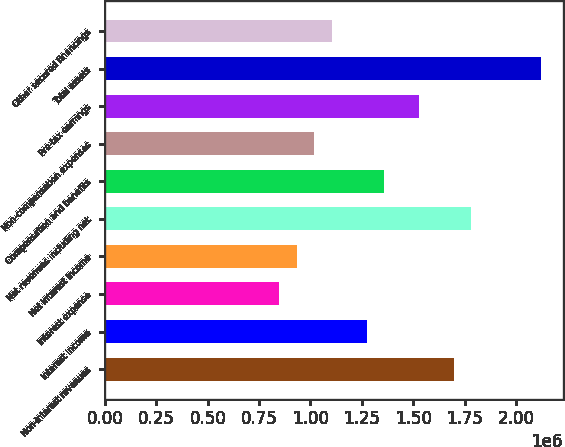Convert chart to OTSL. <chart><loc_0><loc_0><loc_500><loc_500><bar_chart><fcel>Non-interest revenues<fcel>Interest income<fcel>Interest expense<fcel>Net interest income<fcel>Net revenues including net<fcel>Compensation and benefits<fcel>Non-compensation expenses<fcel>Pre-tax earnings<fcel>Total assets<fcel>Other secured financings<nl><fcel>1.69788e+06<fcel>1.27341e+06<fcel>848942<fcel>933836<fcel>1.78278e+06<fcel>1.35831e+06<fcel>1.01873e+06<fcel>1.52809e+06<fcel>2.12235e+06<fcel>1.10362e+06<nl></chart> 